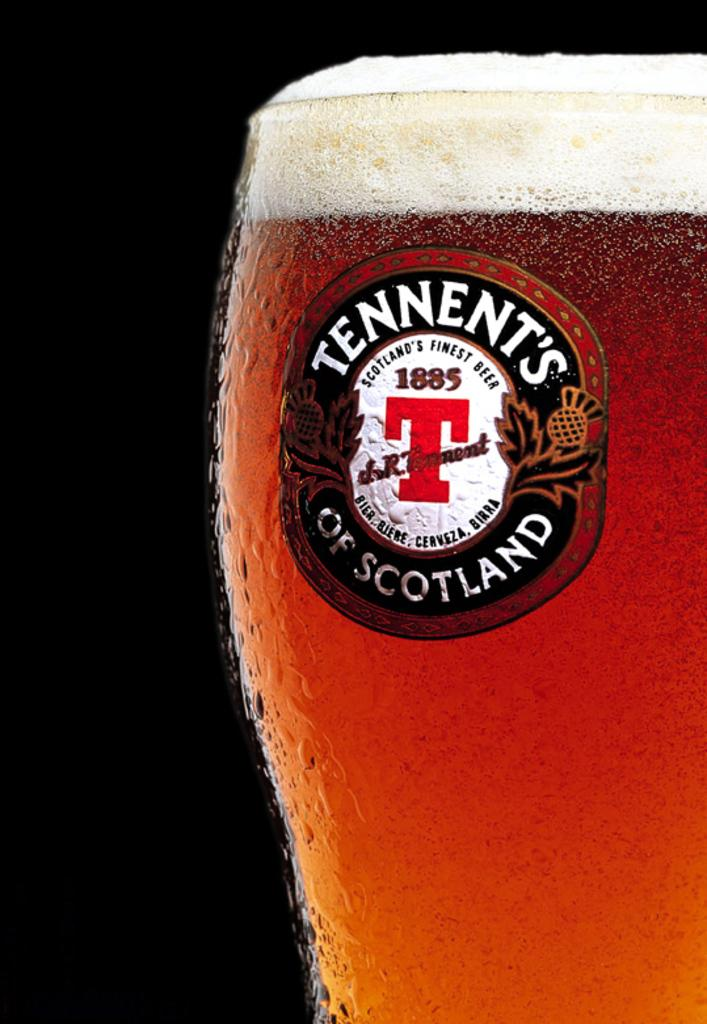<image>
Present a compact description of the photo's key features. A glass full of beer has a lable for Tennent's of Scotland on it. 